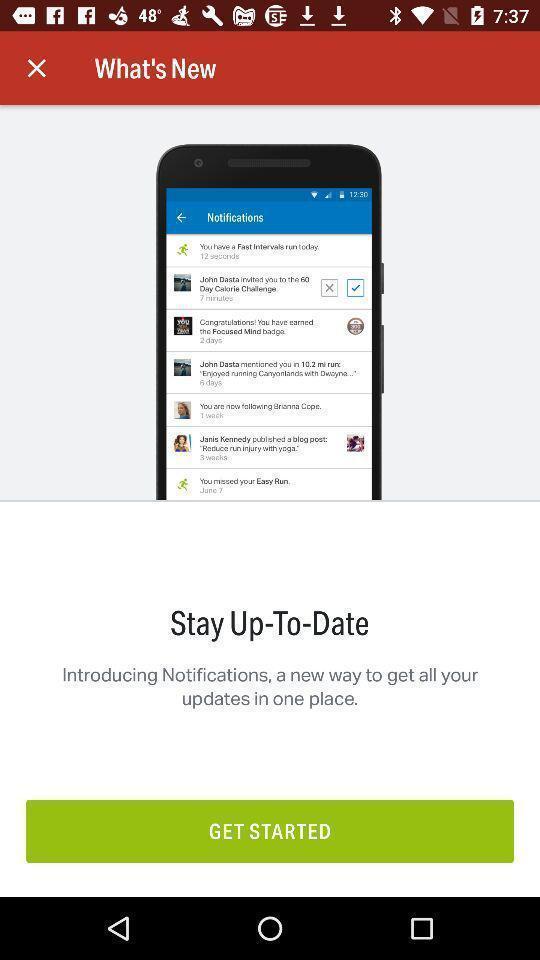What is the overall content of this screenshot? Start page of social networking app. 